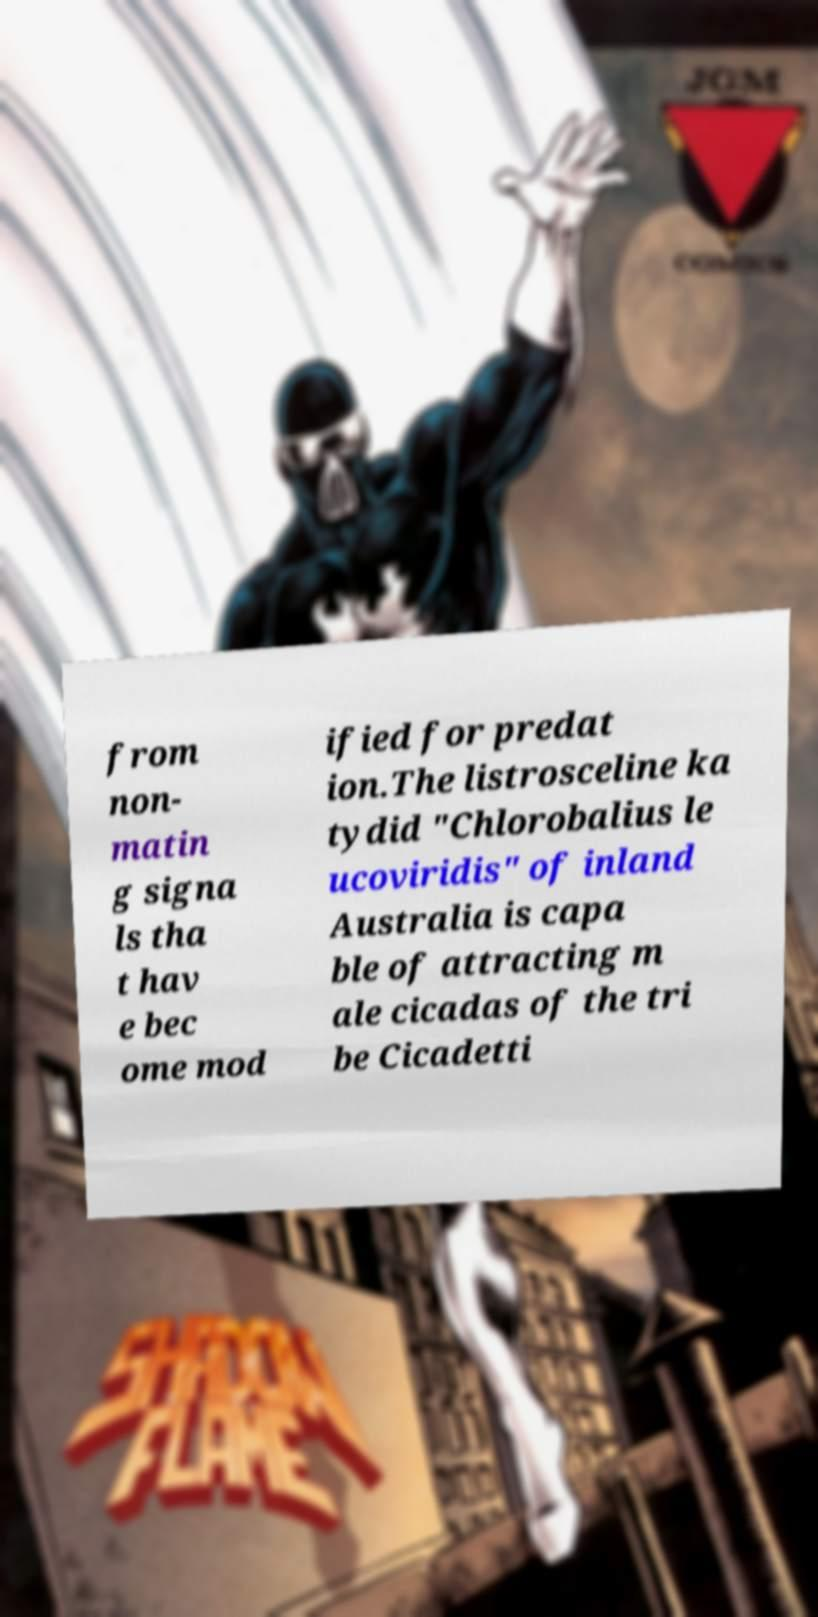For documentation purposes, I need the text within this image transcribed. Could you provide that? from non- matin g signa ls tha t hav e bec ome mod ified for predat ion.The listrosceline ka tydid "Chlorobalius le ucoviridis" of inland Australia is capa ble of attracting m ale cicadas of the tri be Cicadetti 